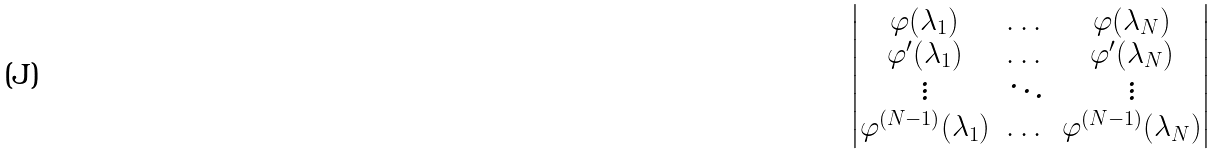Convert formula to latex. <formula><loc_0><loc_0><loc_500><loc_500>\begin{vmatrix} \varphi ( \lambda _ { 1 } ) & \dots & \varphi ( \lambda _ { N } ) \\ \varphi ^ { \prime } ( \lambda _ { 1 } ) & \dots & \varphi ^ { \prime } ( \lambda _ { N } ) \\ \vdots & \ddots & \vdots \\ \varphi ^ { ( N - 1 ) } ( \lambda _ { 1 } ) & \dots & \varphi ^ { ( N - 1 ) } ( \lambda _ { N } ) \end{vmatrix}</formula> 